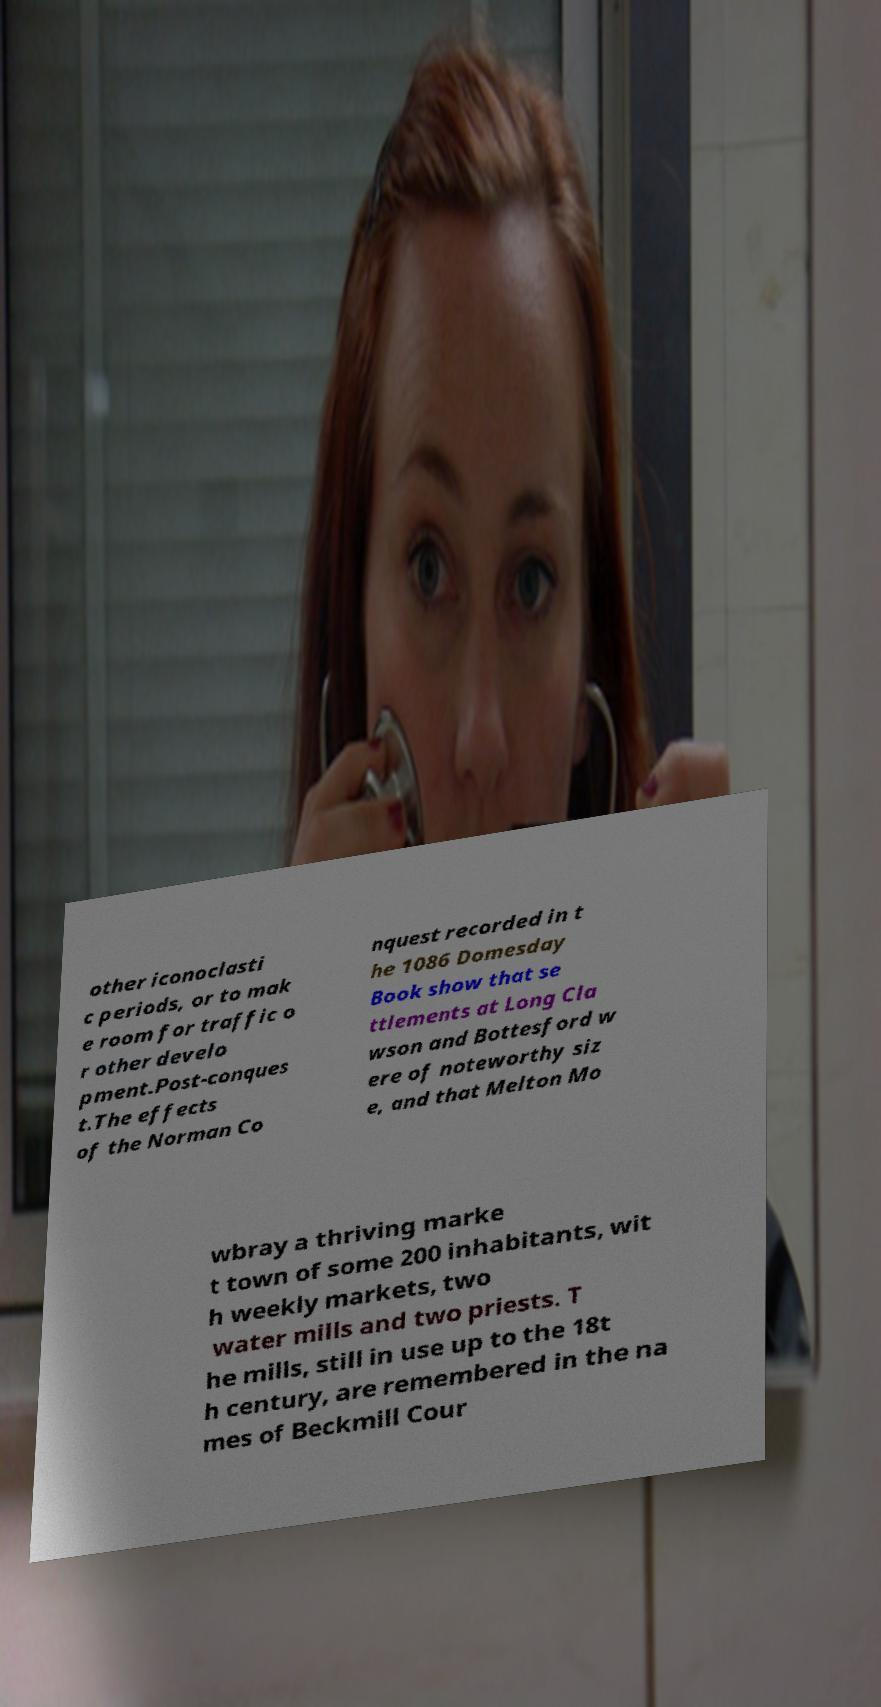Please identify and transcribe the text found in this image. other iconoclasti c periods, or to mak e room for traffic o r other develo pment.Post-conques t.The effects of the Norman Co nquest recorded in t he 1086 Domesday Book show that se ttlements at Long Cla wson and Bottesford w ere of noteworthy siz e, and that Melton Mo wbray a thriving marke t town of some 200 inhabitants, wit h weekly markets, two water mills and two priests. T he mills, still in use up to the 18t h century, are remembered in the na mes of Beckmill Cour 